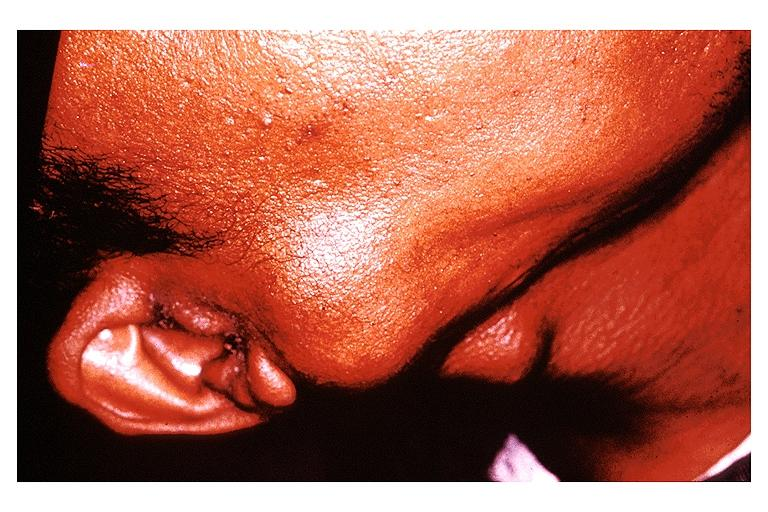what does this image show?
Answer the question using a single word or phrase. Pleomorphic adenoma benign mixed tumor 